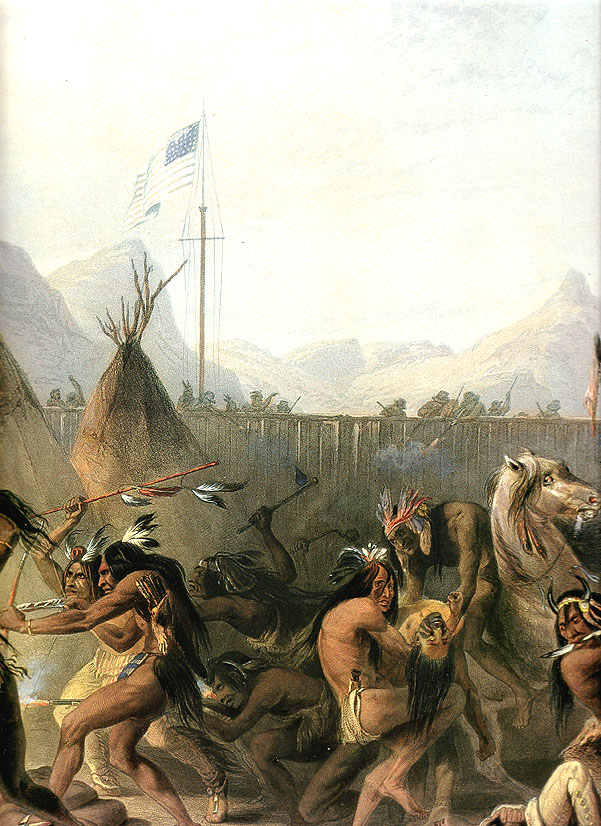What could this scene tell us about the interactions between Native Americans and American settlers? This scene could reveal a great deal about the complex interactions between Native Americans and American settlers. The prominent display of the American flag suggests a moment of diplomacy or a significant event in shared history, perhaps even marking a peaceful encounter or agreement. The lively dance and traditional attire indicate that the Native American way of life was vibrant and integral, despite the presence of foreign influences. This could point to a narrative where both cultures are trying to find common ground and coexist. The painting offers a visual narrative of respect, cultural perseverance, and the complicated nature of historical encounters, where moments of peace and conflict were likely interwoven. Could this dance have specific cultural or spiritual significance? Yes, the dance depicted in the painting likely holds cultural and spiritual significance. Native American dances are often integral parts of rituals and celebrations, used to honor deities, mark important seasonal events, and strengthen communal bonds. In this context, the dance could be part of a ceremonial practice to invoke blessings, celebrate peace, or pay homage to their ancestors. The rhythmic movement, traditional attire, and synchronized harmony of the dancers suggest a deep connection to their cultural roots and spiritual beliefs. The dance could be a manifestation of their prayers, hopes, and gratitude, intricately woven into the fabric of their social and spiritual life. 